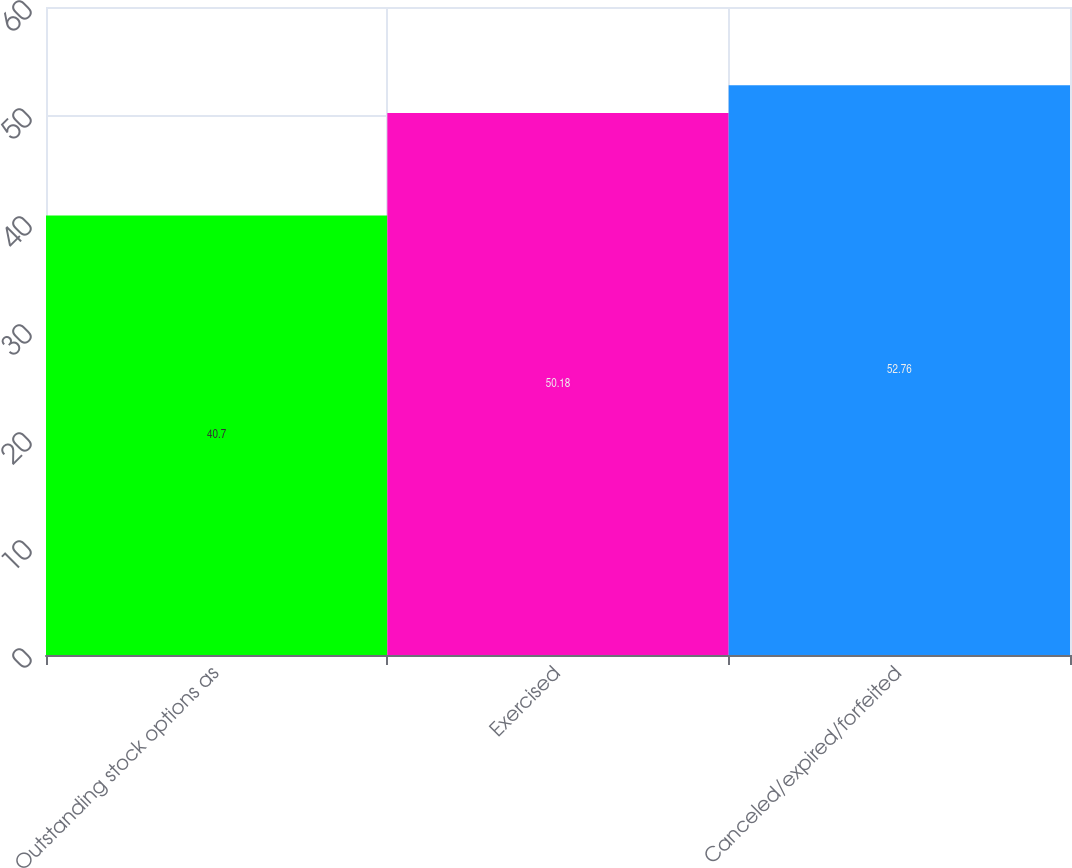<chart> <loc_0><loc_0><loc_500><loc_500><bar_chart><fcel>Outstanding stock options as<fcel>Exercised<fcel>Canceled/expired/forfeited<nl><fcel>40.7<fcel>50.18<fcel>52.76<nl></chart> 